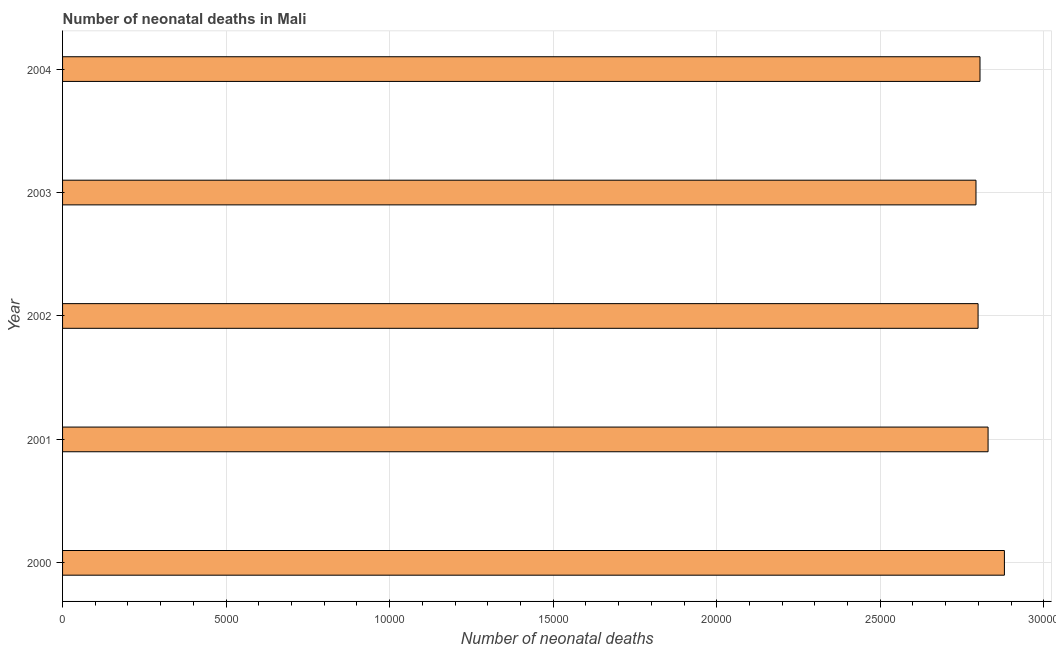Does the graph contain any zero values?
Your answer should be compact. No. What is the title of the graph?
Provide a short and direct response. Number of neonatal deaths in Mali. What is the label or title of the X-axis?
Your answer should be very brief. Number of neonatal deaths. What is the label or title of the Y-axis?
Keep it short and to the point. Year. What is the number of neonatal deaths in 2000?
Offer a terse response. 2.88e+04. Across all years, what is the maximum number of neonatal deaths?
Give a very brief answer. 2.88e+04. Across all years, what is the minimum number of neonatal deaths?
Give a very brief answer. 2.79e+04. In which year was the number of neonatal deaths maximum?
Keep it short and to the point. 2000. In which year was the number of neonatal deaths minimum?
Your response must be concise. 2003. What is the sum of the number of neonatal deaths?
Offer a very short reply. 1.41e+05. What is the average number of neonatal deaths per year?
Provide a succinct answer. 2.82e+04. What is the median number of neonatal deaths?
Your response must be concise. 2.80e+04. In how many years, is the number of neonatal deaths greater than 4000 ?
Make the answer very short. 5. What is the ratio of the number of neonatal deaths in 2002 to that in 2003?
Your response must be concise. 1. Is the number of neonatal deaths in 2003 less than that in 2004?
Give a very brief answer. Yes. Is the difference between the number of neonatal deaths in 2000 and 2004 greater than the difference between any two years?
Offer a very short reply. No. What is the difference between the highest and the second highest number of neonatal deaths?
Provide a short and direct response. 499. What is the difference between the highest and the lowest number of neonatal deaths?
Your response must be concise. 869. In how many years, is the number of neonatal deaths greater than the average number of neonatal deaths taken over all years?
Your answer should be very brief. 2. Are the values on the major ticks of X-axis written in scientific E-notation?
Your answer should be compact. No. What is the Number of neonatal deaths of 2000?
Offer a very short reply. 2.88e+04. What is the Number of neonatal deaths in 2001?
Your answer should be compact. 2.83e+04. What is the Number of neonatal deaths of 2002?
Provide a short and direct response. 2.80e+04. What is the Number of neonatal deaths in 2003?
Your answer should be compact. 2.79e+04. What is the Number of neonatal deaths in 2004?
Your answer should be compact. 2.80e+04. What is the difference between the Number of neonatal deaths in 2000 and 2001?
Your answer should be compact. 499. What is the difference between the Number of neonatal deaths in 2000 and 2002?
Offer a very short reply. 805. What is the difference between the Number of neonatal deaths in 2000 and 2003?
Make the answer very short. 869. What is the difference between the Number of neonatal deaths in 2000 and 2004?
Offer a terse response. 746. What is the difference between the Number of neonatal deaths in 2001 and 2002?
Your answer should be very brief. 306. What is the difference between the Number of neonatal deaths in 2001 and 2003?
Provide a succinct answer. 370. What is the difference between the Number of neonatal deaths in 2001 and 2004?
Your answer should be compact. 247. What is the difference between the Number of neonatal deaths in 2002 and 2004?
Keep it short and to the point. -59. What is the difference between the Number of neonatal deaths in 2003 and 2004?
Give a very brief answer. -123. What is the ratio of the Number of neonatal deaths in 2000 to that in 2002?
Offer a terse response. 1.03. What is the ratio of the Number of neonatal deaths in 2000 to that in 2003?
Ensure brevity in your answer.  1.03. What is the ratio of the Number of neonatal deaths in 2000 to that in 2004?
Your answer should be very brief. 1.03. What is the ratio of the Number of neonatal deaths in 2001 to that in 2002?
Your answer should be compact. 1.01. What is the ratio of the Number of neonatal deaths in 2002 to that in 2003?
Your answer should be very brief. 1. What is the ratio of the Number of neonatal deaths in 2003 to that in 2004?
Your response must be concise. 1. 